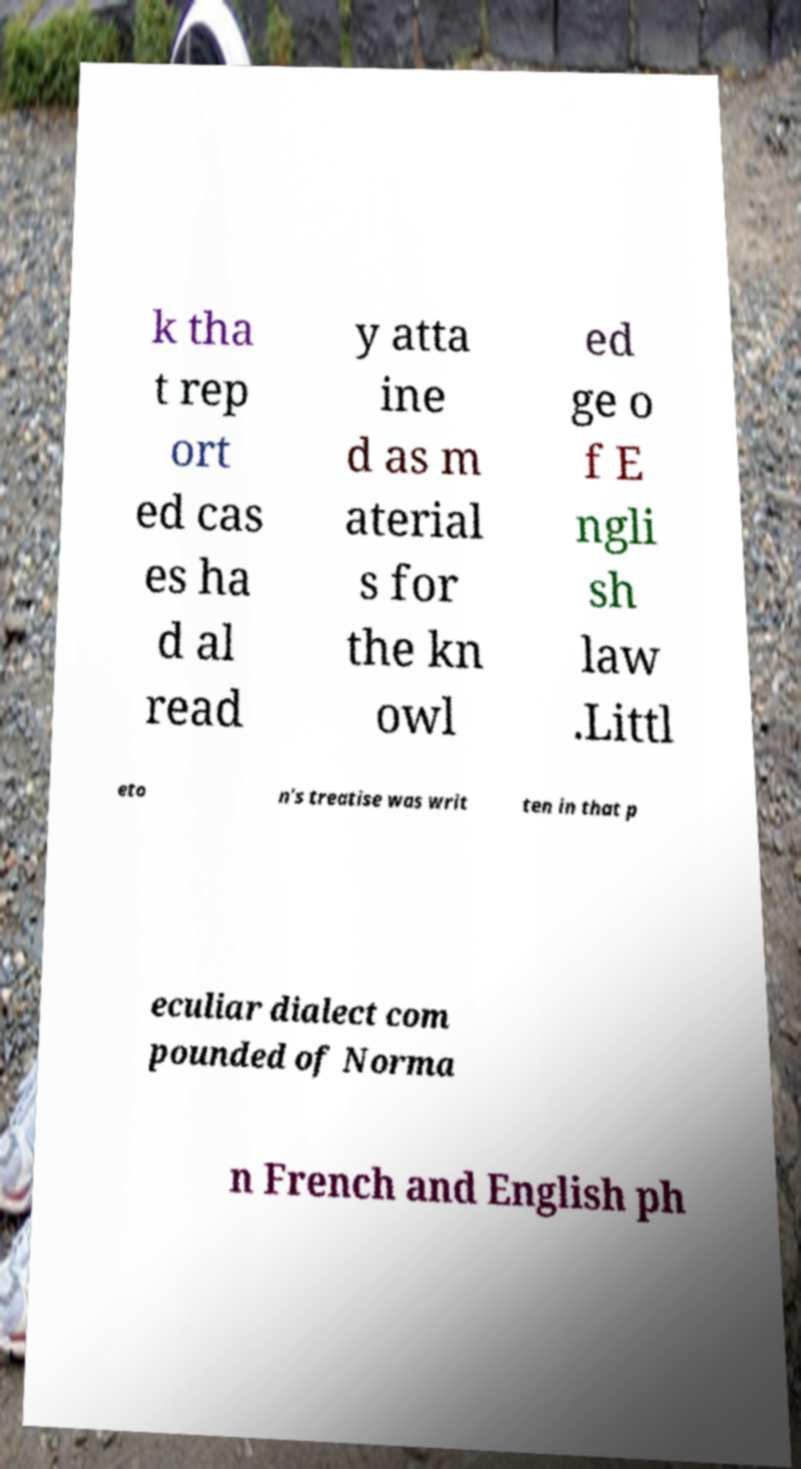I need the written content from this picture converted into text. Can you do that? k tha t rep ort ed cas es ha d al read y atta ine d as m aterial s for the kn owl ed ge o f E ngli sh law .Littl eto n's treatise was writ ten in that p eculiar dialect com pounded of Norma n French and English ph 